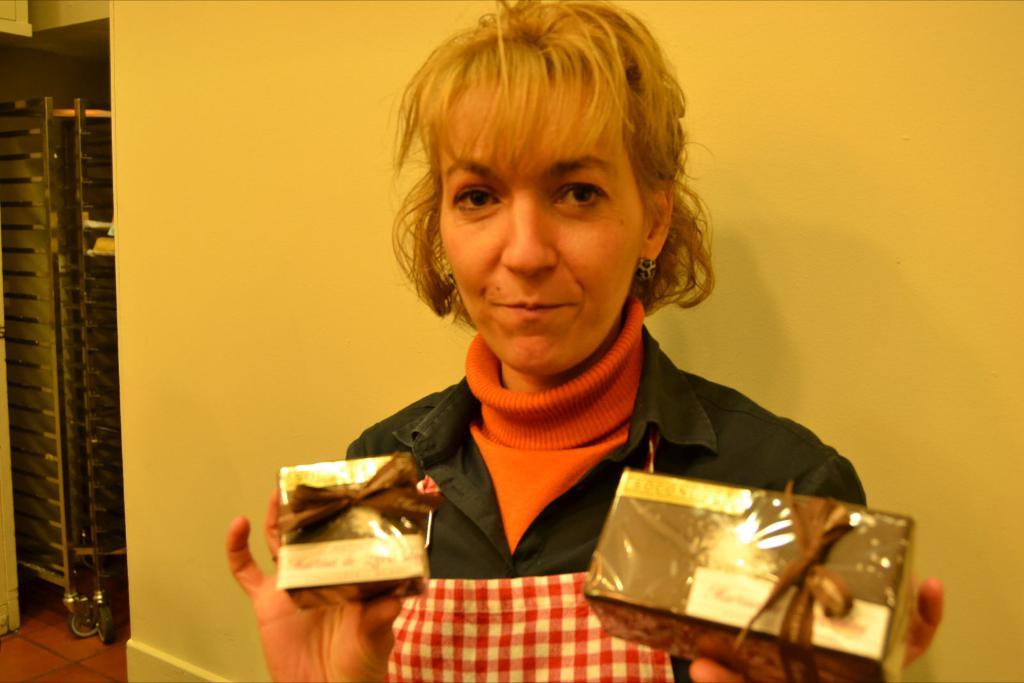Who is present in the image? There is a woman in the image. What is the woman wearing? The woman is wearing an apron. What is the woman holding in the image? The woman is holding gift boxes. What is the woman's facial expression? The woman is smiling. What can be seen in the background of the image? There is a wall and an object on the floor in the background. What scientific theory is the woman discussing in the image? There is no indication in the image that the woman is discussing a scientific theory. 